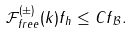Convert formula to latex. <formula><loc_0><loc_0><loc_500><loc_500>\| \mathcal { F } _ { f r e e } ^ { ( \pm ) } ( k ) f \| _ { h } \leq C \| f \| _ { \mathcal { B } } .</formula> 